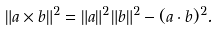Convert formula to latex. <formula><loc_0><loc_0><loc_500><loc_500>\| a \times b \| ^ { 2 } = \| a \| ^ { 2 } \| b \| ^ { 2 } - ( a \cdot b ) ^ { 2 } .</formula> 